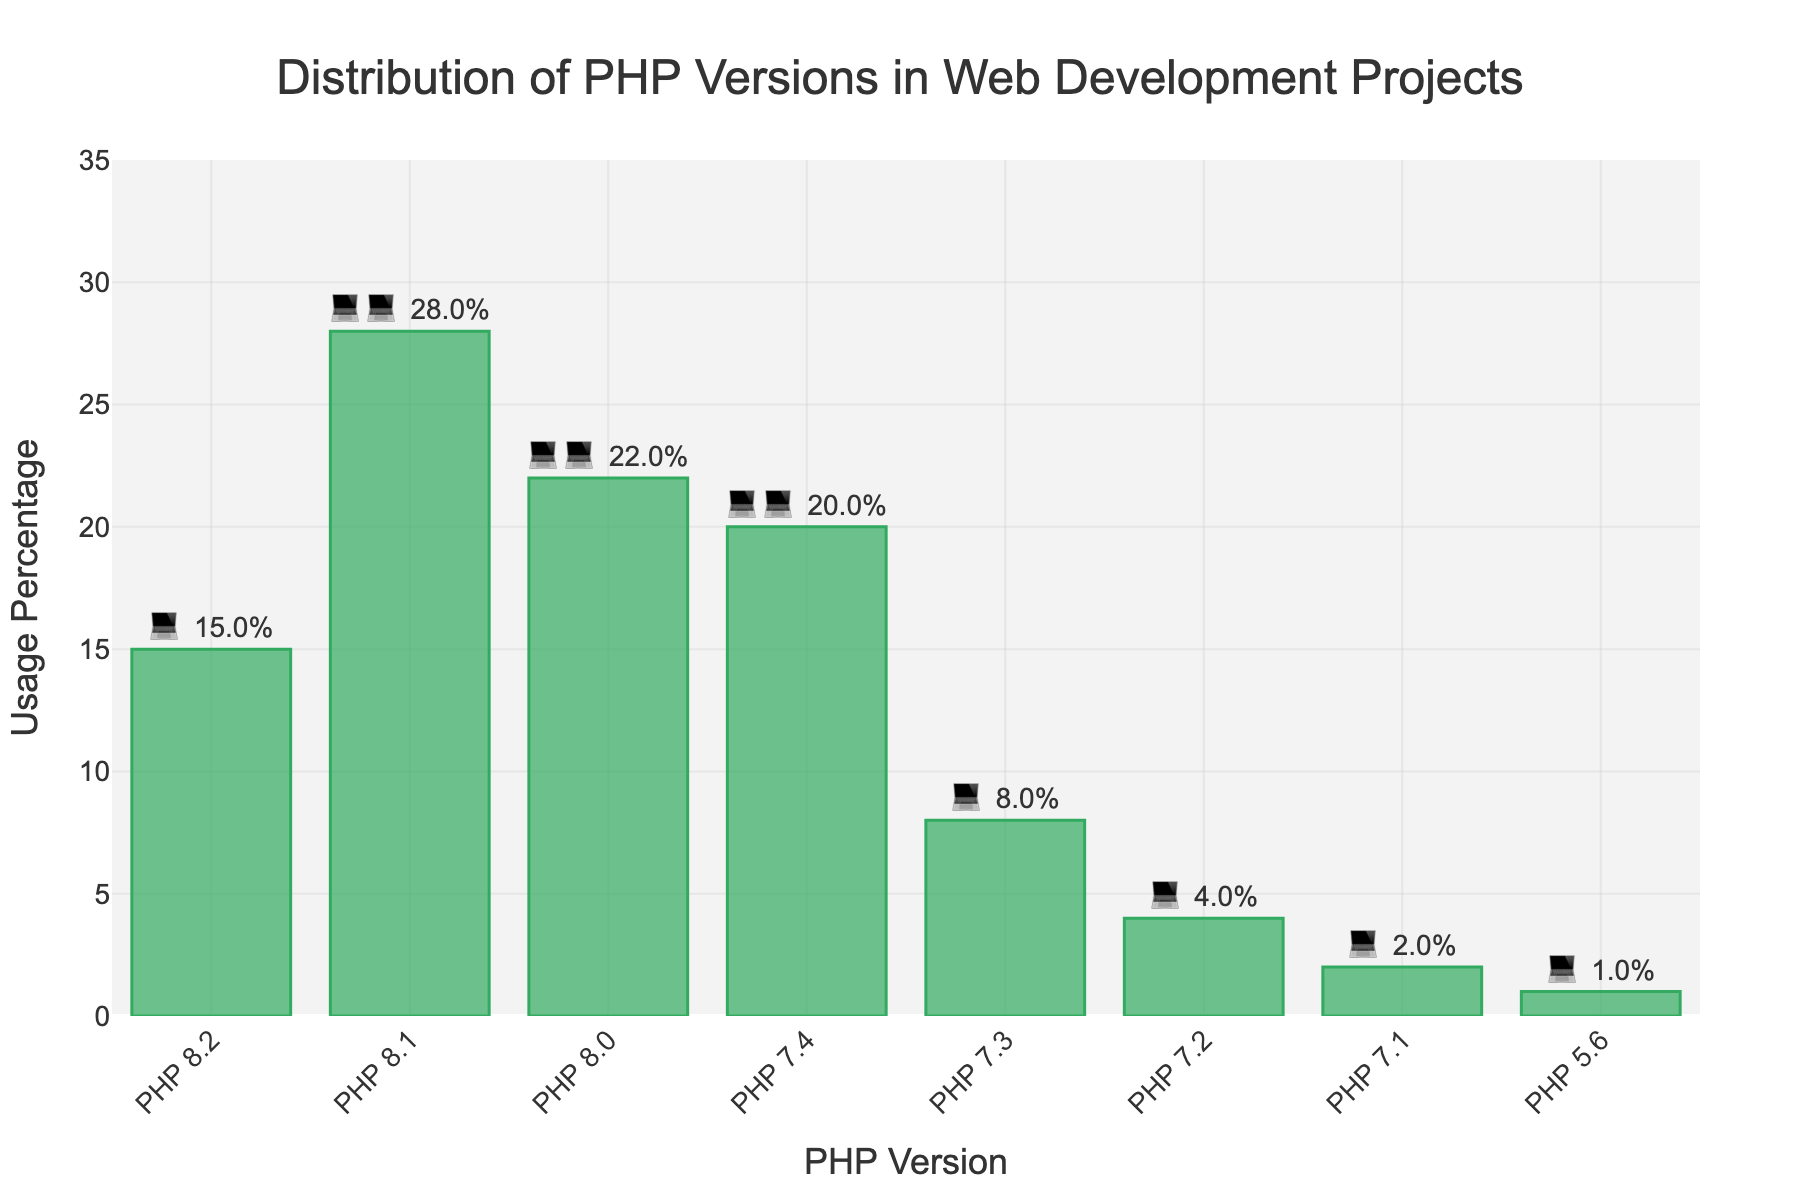Which PHP version has the highest usage percentage? The figure shows the usage percentages for different PHP versions, and the highest percentage can be observed by identifying the tallest bar. PHP 8.1 has the highest usage percentage at 28%.
Answer: PHP 8.1 What's the total usage percentage of PHP versions 8.2 and 8.0? To find the total usage percentage, add the individual usage percentages of PHP 8.2 (15%) and PHP 8.0 (22%). The sum is 15% + 22% = 37%.
Answer: 37% Which PHP version has the lowest usage percentage? The figure shows the usage percentages for different PHP versions, and the lowest percentage can be observed by identifying the shortest bar. PHP 5.6 has the lowest usage percentage at 1%.
Answer: PHP 5.6 How much more popular is PHP 8.1 compared to PHP 7.3? Subtract the usage percentage of PHP 7.3 (8%) from the usage percentage of PHP 8.1 (28%). The difference is 28% - 8% = 20%.
Answer: 20% What is the average usage percentage of all PHP versions? To find the average usage percentage, sum all the usage percentages and divide by the number of PHP versions. The sum is 15% + 28% + 22% + 20% + 8% + 4% + 2% + 1% = 100%. There are 8 versions, so the average is 100% / 8 = 12.5%.
Answer: 12.5% Which PHP versions are used by less than 10% of projects? To find the versions used by less than 10% of projects, look for bars with usage percentages less than 10%. PHP 7.3 (8%), PHP 7.2 (4%), PHP 7.1 (2%), and PHP 5.6 (1%) are used by less than 10% of projects.
Answer: PHP 7.3, PHP 7.2, PHP 7.1, PHP 5.6 How many PHP versions have usage percentages below the average usage percentage? The average usage percentage is 12.5%. Count the PHP versions with usage percentages below this average: PHP 7.3 (8%), PHP 7.2 (4%), PHP 7.1 (2%), and PHP 5.6 (1%) are below 12.5%. So, there are 4 versions below the average.
Answer: 4 What is the combined usage percentage of all PHP 7.x versions (7.4, 7.3, 7.2, 7.1)? Sum the usage percentages of all PHP 7.x versions: 7.4 (20%), 7.3 (8%), 7.2 (4%), and 7.1 (2%). The sum is 20% + 8% + 4% + 2% = 34%.
Answer: 34% Which two PHP versions have the closest usage percentages? Comparing the usage percentages of all PHP versions, PHP 8.0 (22%) and PHP 7.4 (20%) have the closest usage percentages with a difference of 2%.
Answer: PHP 8.0 and PHP 7.4 